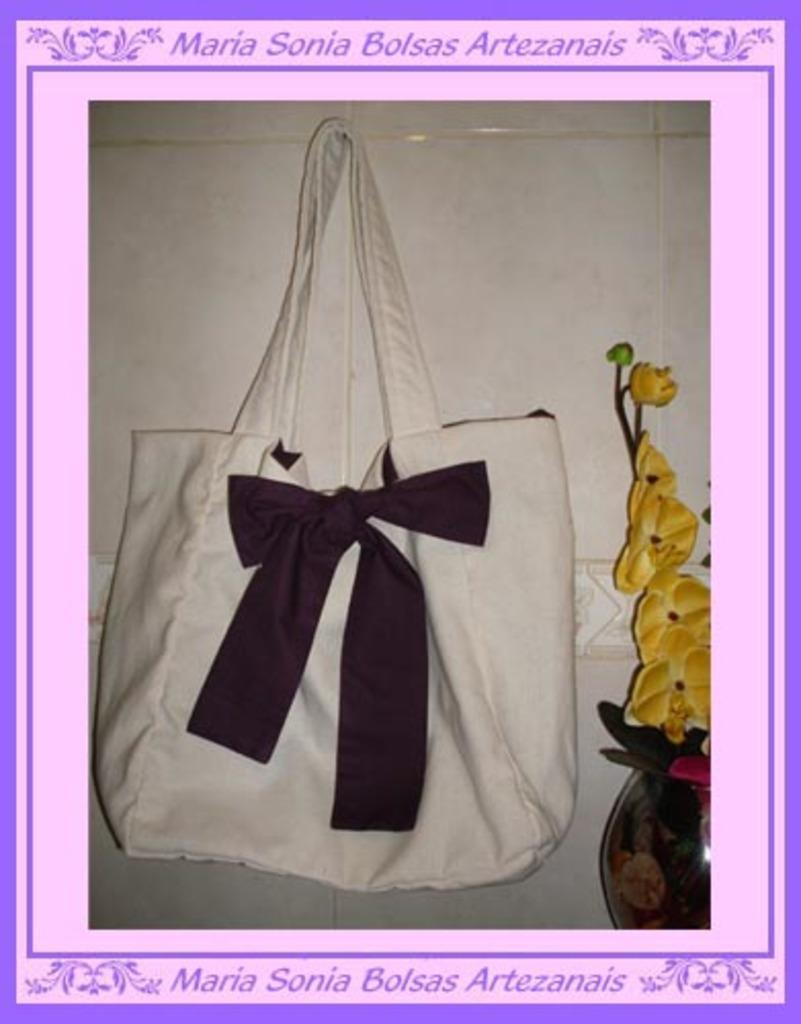Can you describe this image briefly? As we can see in the image there are white color tiles, bag and flowers. 